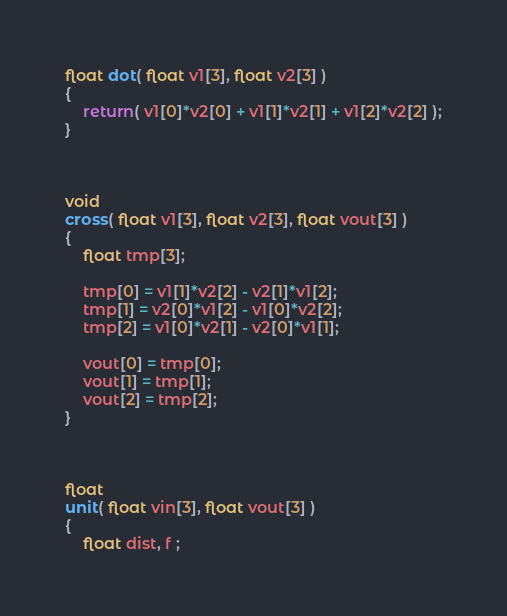Convert code to text. <code><loc_0><loc_0><loc_500><loc_500><_C++_>

float dot( float v1[3], float v2[3] )
{
	return( v1[0]*v2[0] + v1[1]*v2[1] + v1[2]*v2[2] );
}



void
cross( float v1[3], float v2[3], float vout[3] )
{
	float tmp[3];

	tmp[0] = v1[1]*v2[2] - v2[1]*v1[2];
	tmp[1] = v2[0]*v1[2] - v1[0]*v2[2];
	tmp[2] = v1[0]*v2[1] - v2[0]*v1[1];

	vout[0] = tmp[0];
	vout[1] = tmp[1];
	vout[2] = tmp[2];
}



float
unit( float vin[3], float vout[3] )
{
	float dist, f ;
</code> 